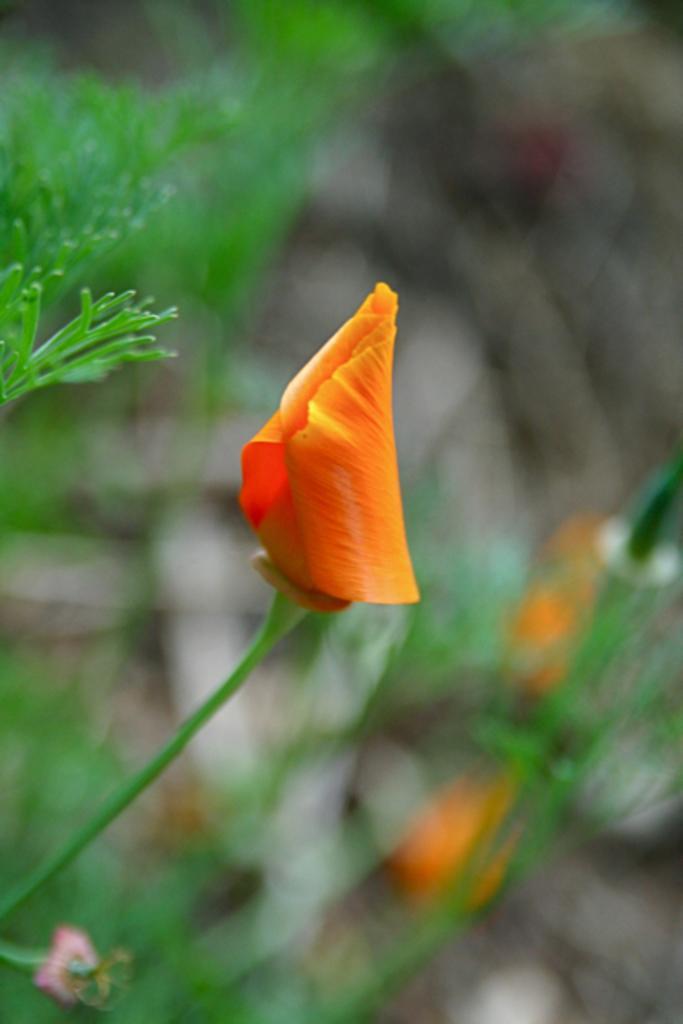How would you summarize this image in a sentence or two? In the front of the image I can see a flower and stem. In the background of the image it is blurry. 